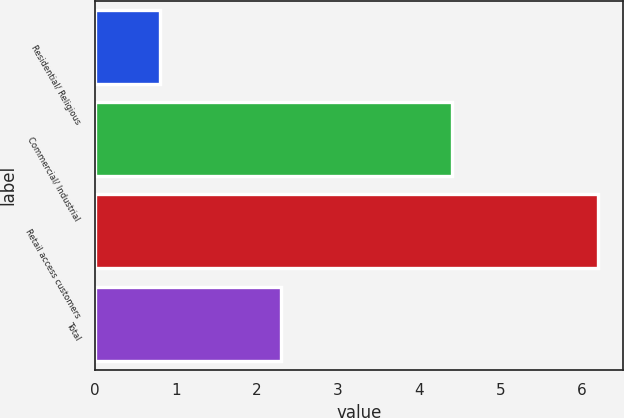Convert chart. <chart><loc_0><loc_0><loc_500><loc_500><bar_chart><fcel>Residential/ Religious<fcel>Commercial/ Industrial<fcel>Retail access customers<fcel>Total<nl><fcel>0.8<fcel>4.4<fcel>6.2<fcel>2.3<nl></chart> 